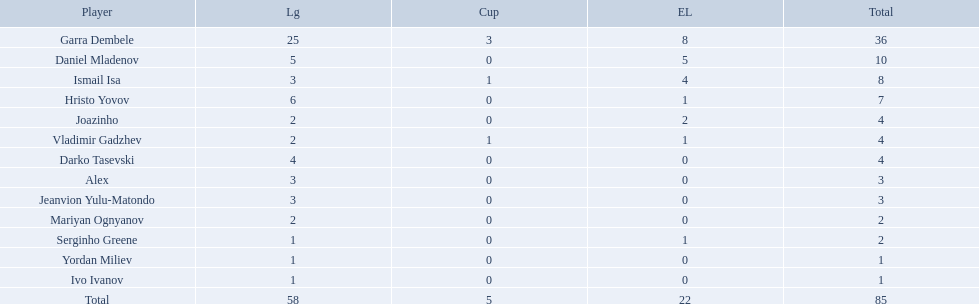Who are all of the players? Garra Dembele, Daniel Mladenov, Ismail Isa, Hristo Yovov, Joazinho, Vladimir Gadzhev, Darko Tasevski, Alex, Jeanvion Yulu-Matondo, Mariyan Ognyanov, Serginho Greene, Yordan Miliev, Ivo Ivanov. And which league is each player in? 25, 5, 3, 6, 2, 2, 4, 3, 3, 2, 1, 1, 1. Along with vladimir gadzhev and joazinho, which other player is in league 2? Mariyan Ognyanov. 